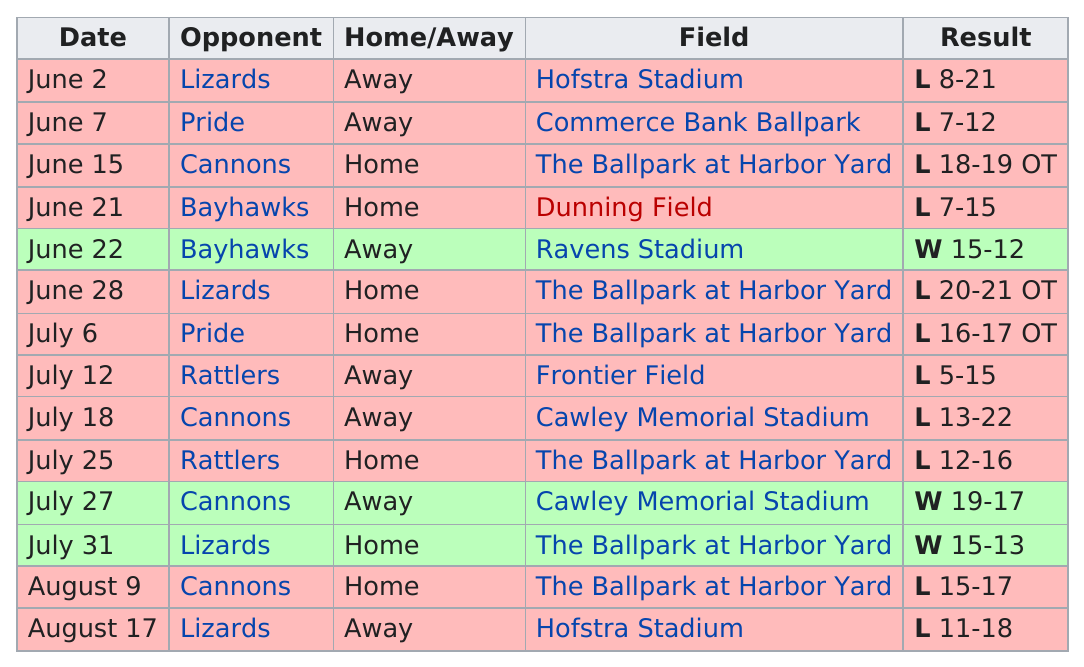Draw attention to some important aspects in this diagram. The barrage has scored an impressive 20 points at home, the most in their history The opponent prior to the pride was the Lizards. The barrage and the lizards have played against each other 4 times. The Barrage have achieved an impressive 2 consecutive wins this season, a testament to their dominance on the field. The outcome of the match is unclear, as it is unknown whether the team won more at home or away. 